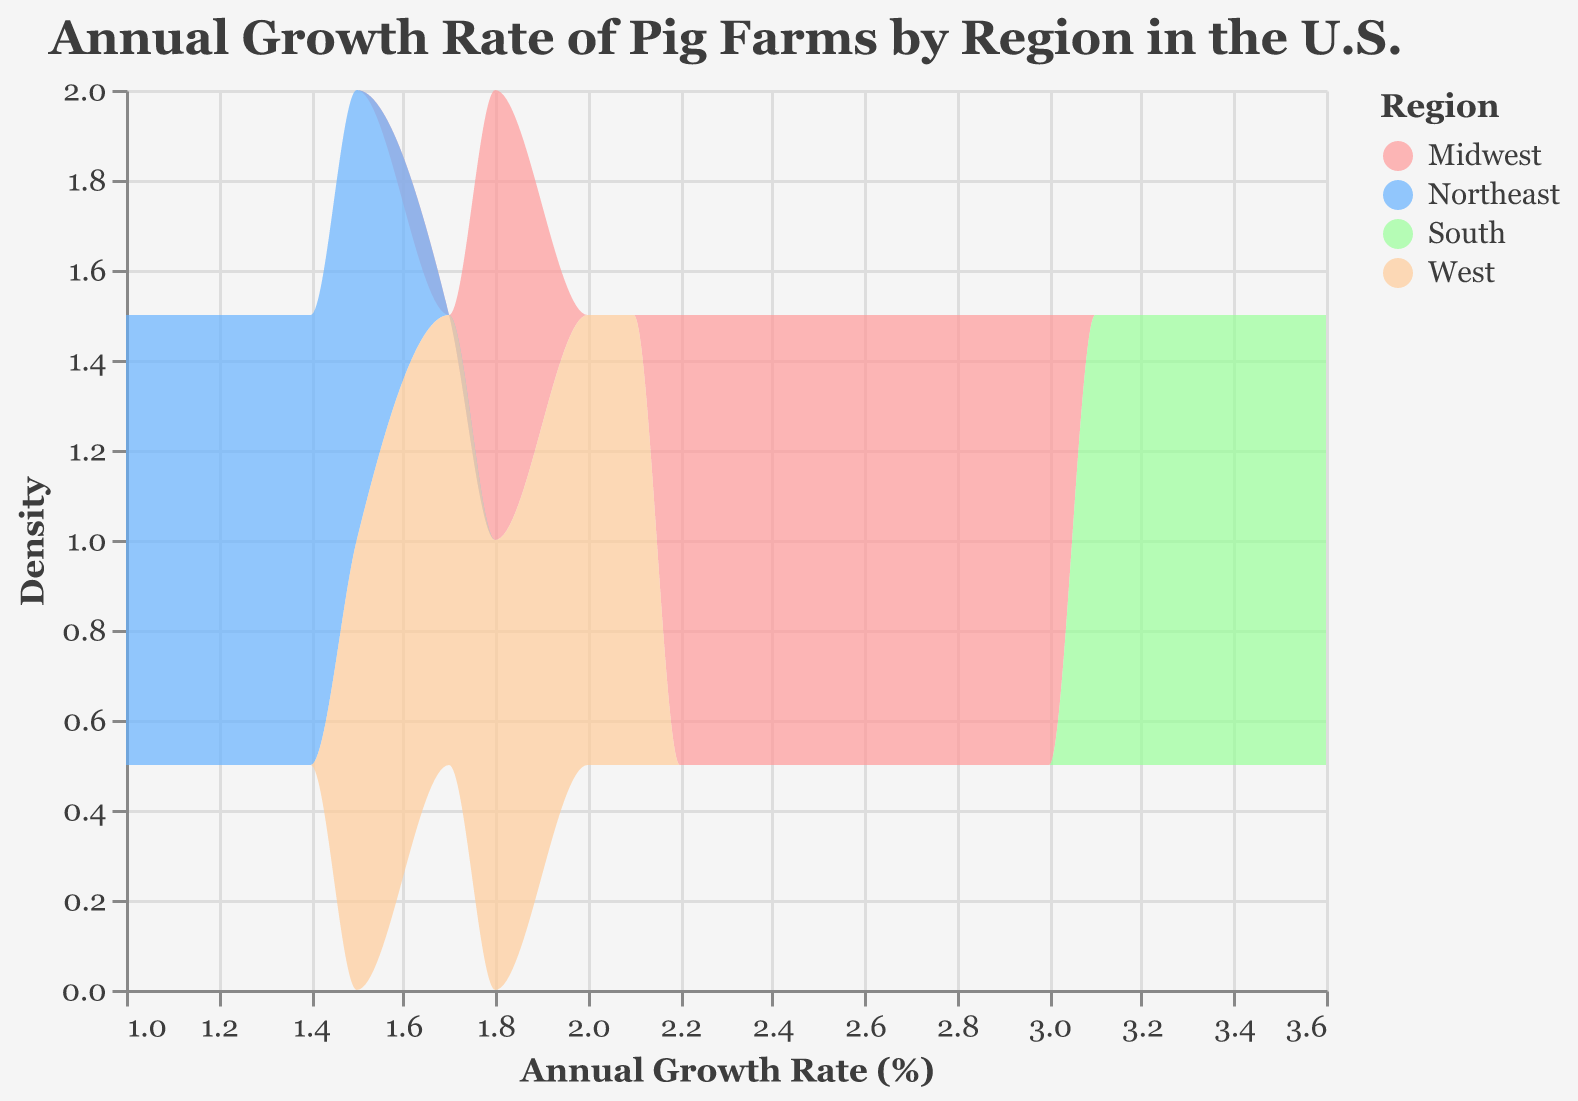What regions are included in the density plot? The plot's color legend indicates the regions included, which are the Midwest, Northeast, South, and West.
Answer: Midwest, Northeast, South, West What's the range of the annual growth rates displayed on the x-axis? By looking at the x-axis, we can see that the annual growth rates range from 1.0% to 3.6%.
Answer: 1.0% to 3.6% Which region shows the greatest variability in annual growth rates? From the density plot, the South region has data points spread out across a wider range, showing greater variability in annual growth rates.
Answer: South What is the approximate highest density value for any region, and which region does it belong to? By observing the peak of the density curves, the South region seems to have the highest density peak at around 2-3 annual growth rate occurrences.
Answer: Around 2-3, South Which region has the lowest density at its peak, and what is this value? The Northeast region has the lowest density peak, as seen by its lower curve height, approximating a density value of around 1.3.
Answer: Around 1.3, Northeast Which region has an annual growth rate consistently above 3.0%? By analyzing the plot, the South region has annual growth rates consistently above 3.0% and no other regions share this trait.
Answer: South In which years does the Midwest region's growth rate drop below 2.0%, if at all? The Midwest region's annual growth rate drops below 2.0% in the year 2020, as indicated by the provided data points.
Answer: 2020 Comparing the West and the Northeast, which region has a higher average annual growth rate? By comparing the density curves and data points, the West region has a higher average annual growth rate than the Northeast region.
Answer: West What year does the Northeast show its lowest annual growth rate, and what is the value? By referencing the data points, the Northeast's lowest annual growth rate occurs in 2020, with a value of 1.0%.
Answer: 2020, 1.0% How many regions show at least one year with an annual growth rate greater than 3.0%? By reviewing the plot, both the Midwest and South regions show at least one year with an annual growth rate greater than 3.0%.
Answer: Two regions 